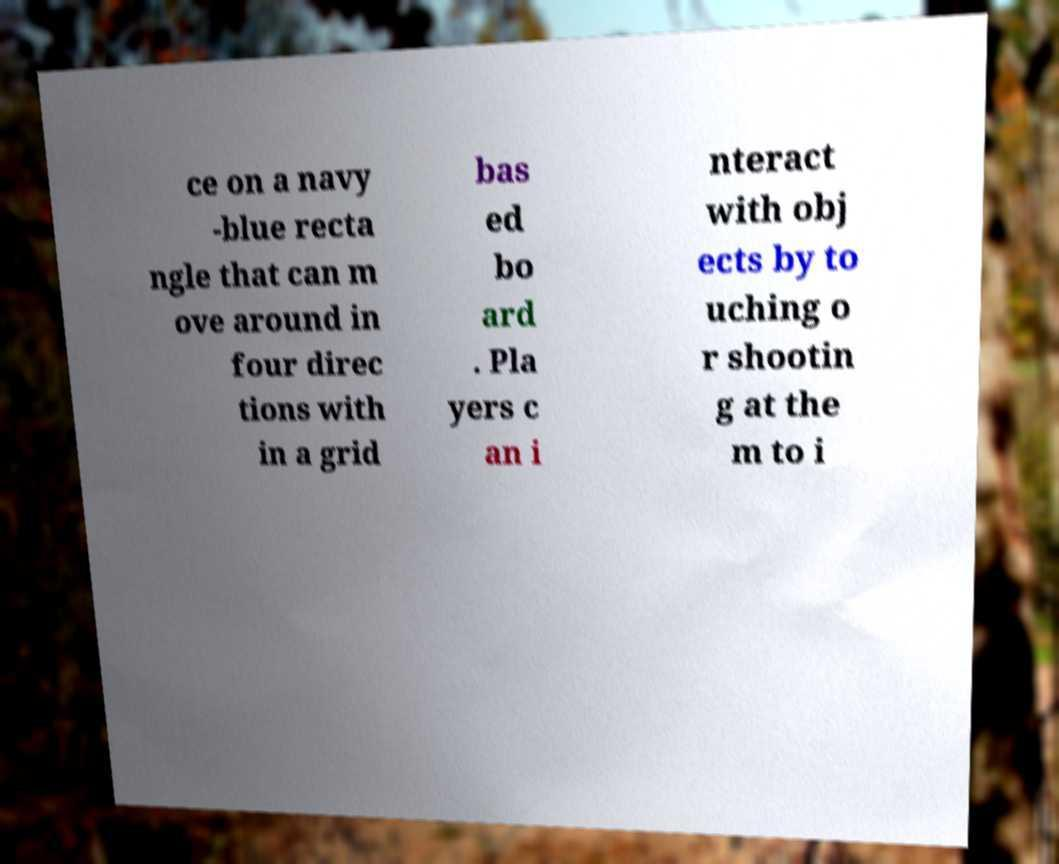For documentation purposes, I need the text within this image transcribed. Could you provide that? ce on a navy -blue recta ngle that can m ove around in four direc tions with in a grid bas ed bo ard . Pla yers c an i nteract with obj ects by to uching o r shootin g at the m to i 